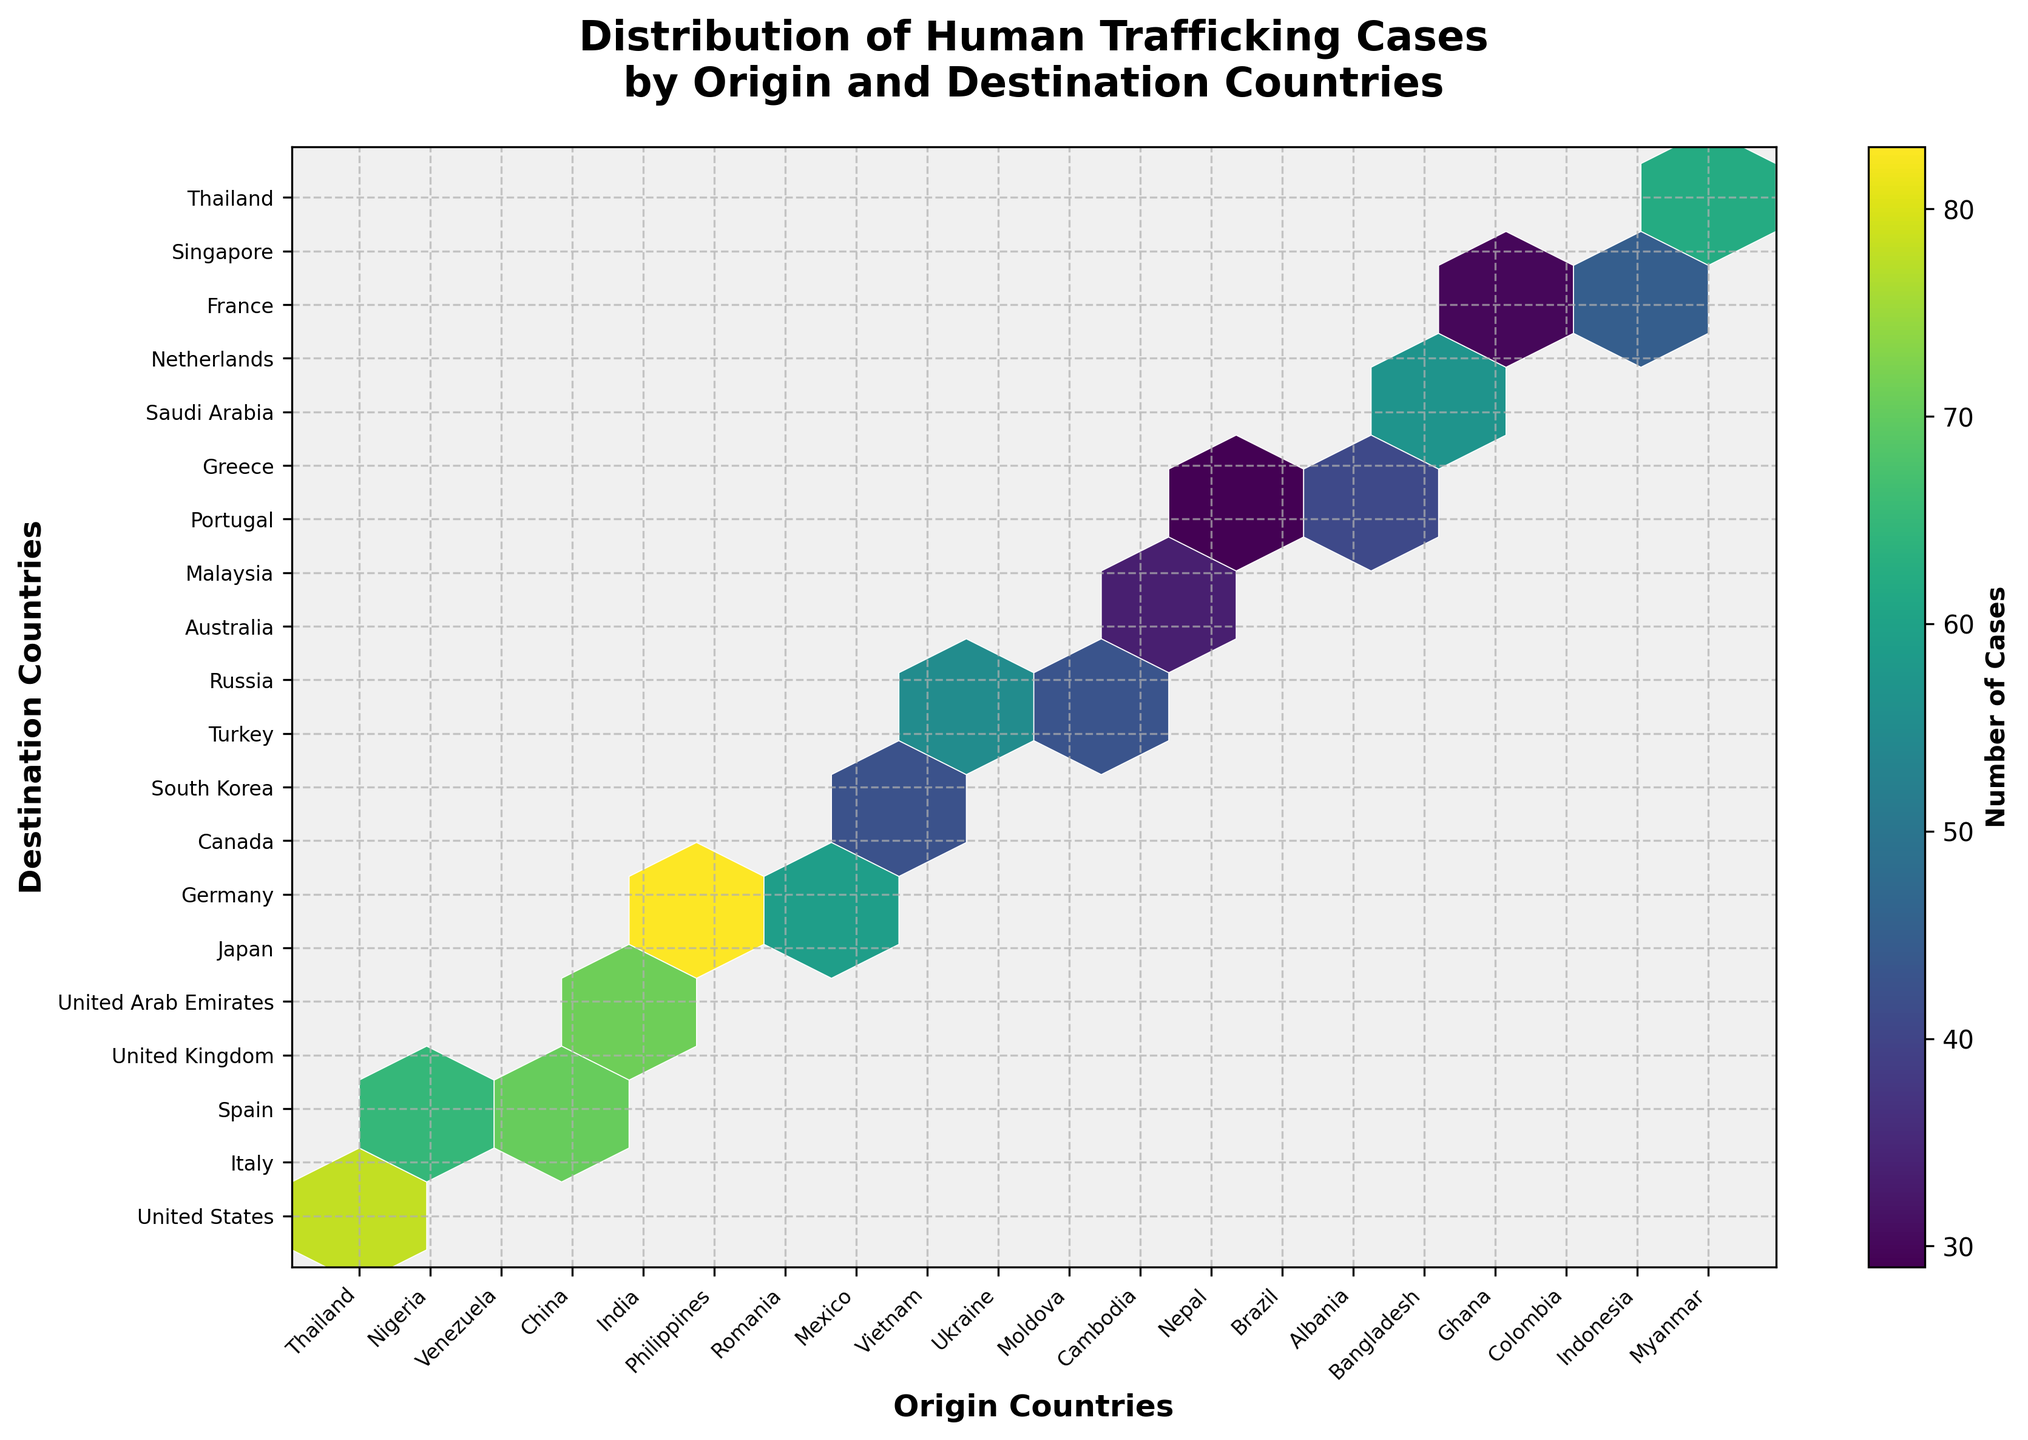What is the title of the hexbin plot? The title is usually placed at the top of the plot. In this case, the title clearly states the content of the figure.
Answer: Distribution of Human Trafficking Cases by Origin and Destination Countries Which origin country has human trafficking cases in the United States? Look at the y-axis for 'United States' and trace back to the corresponding x-axis label.
Answer: Thailand How many human trafficking cases are there from China to the United Kingdom? Identify the origin country ('China') on the x-axis and the destination country ('United Kingdom') on the y-axis, then see the color intensity or hexbin value.
Answer: 89 Which destination country has trafficking cases from Brazil? Locate 'Brazil' on the x-axis and trace the respective y-axis category.
Answer: Portugal Compare the number of cases from Nigeria to Italy and from Thailand to the United States. Which is higher? Identify the hexbin colors associated with these pairs (Nigeria to Italy and Thailand to the US) and compare. Thailand to the US will have a more intense color (78) than Nigeria to Italy (65).
Answer: Thailand to the United States is higher What is the sum of human trafficking cases from Myanmar to Thailand and Vietnam to South Korea? Identify the hexbin values for Myanmar to Thailand (62) and Vietnam to South Korea (38) and add them. 62 + 38 = 100
Answer: 100 Which origin-destination pair has the lowest number of human trafficking cases? Identify the hexbin with the lightest color or lowest intensity, referencing the color bar if necessary. The Cambodia to Australia pair has cases marked as 31.
Answer: Cambodia to Australia How many origin countries are represented in this plot? Count the unique labels on the x-axis.
Answer: 20 What does the coloring in the hexbin represent? The color bar and legend typically explain this. In this plot, it represents the number of human trafficking cases.
Answer: Number of Cases What pattern do you observe in terms of the most common destination region for trafficking victims? By looking at the y-axis and the destination countries associated with higher counts (darker hexbin colors), common destinations include Western countries like the United States, United Kingdom, and European countries.
Answer: Western and European countries 